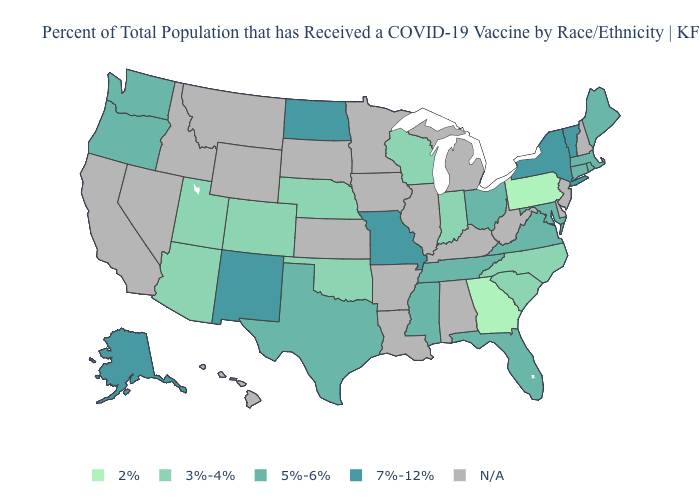How many symbols are there in the legend?
Concise answer only. 5. What is the value of Iowa?
Be succinct. N/A. What is the value of Mississippi?
Give a very brief answer. 5%-6%. Among the states that border Rhode Island , which have the highest value?
Concise answer only. Connecticut, Massachusetts. How many symbols are there in the legend?
Quick response, please. 5. What is the highest value in the West ?
Answer briefly. 7%-12%. Among the states that border Arkansas , does Oklahoma have the lowest value?
Short answer required. Yes. Name the states that have a value in the range 2%?
Give a very brief answer. Georgia, Pennsylvania. Which states have the lowest value in the USA?
Short answer required. Georgia, Pennsylvania. Does Pennsylvania have the lowest value in the USA?
Give a very brief answer. Yes. Among the states that border Colorado , which have the lowest value?
Write a very short answer. Arizona, Nebraska, Oklahoma, Utah. Among the states that border Illinois , does Missouri have the highest value?
Keep it brief. Yes. Among the states that border Illinois , does Missouri have the lowest value?
Give a very brief answer. No. 